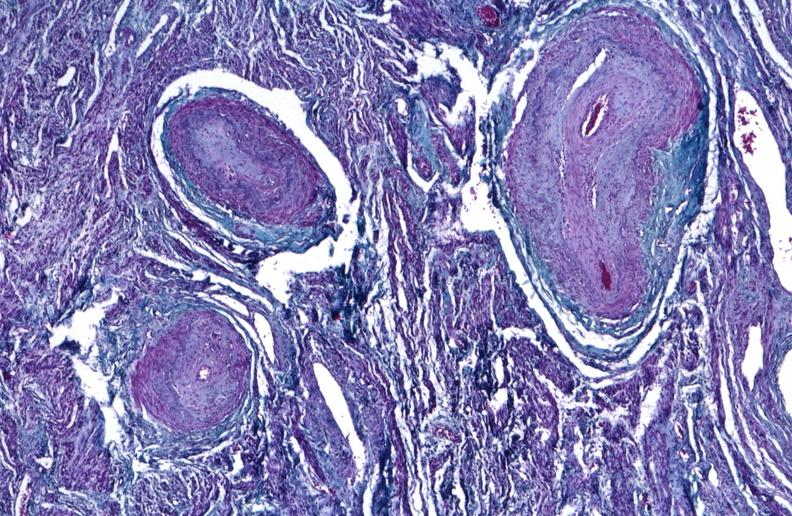does this image show kidney, polyarteritis nodosa?
Answer the question using a single word or phrase. Yes 